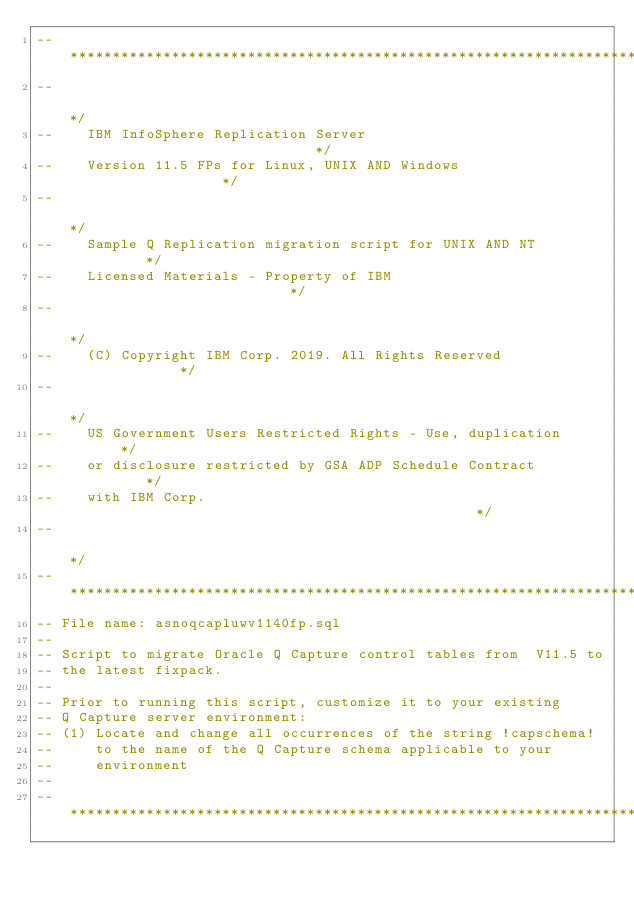Convert code to text. <code><loc_0><loc_0><loc_500><loc_500><_SQL_>--********************************************************************/
--                                                                   */
--    IBM InfoSphere Replication Server                              */
--    Version 11.5 FPs for Linux, UNIX AND Windows                   */
--                                                                   */
--    Sample Q Replication migration script for UNIX AND NT          */
--    Licensed Materials - Property of IBM                           */
--                                                                   */
--    (C) Copyright IBM Corp. 2019. All Rights Reserved              */
--                                                                   */
--    US Government Users Restricted Rights - Use, duplication       */
--    or disclosure restricted by GSA ADP Schedule Contract          */
--    with IBM Corp.                                                 */
--                                                                   */
--********************************************************************/
-- File name: asnoqcapluwv1140fp.sql
--
-- Script to migrate Oracle Q Capture control tables from  V11.5 to
-- the latest fixpack.
--
-- Prior to running this script, customize it to your existing
-- Q Capture server environment:
-- (1) Locate and change all occurrences of the string !capschema!
--     to the name of the Q Capture schema applicable to your
--     environment
--
--********************************************************************/


</code> 